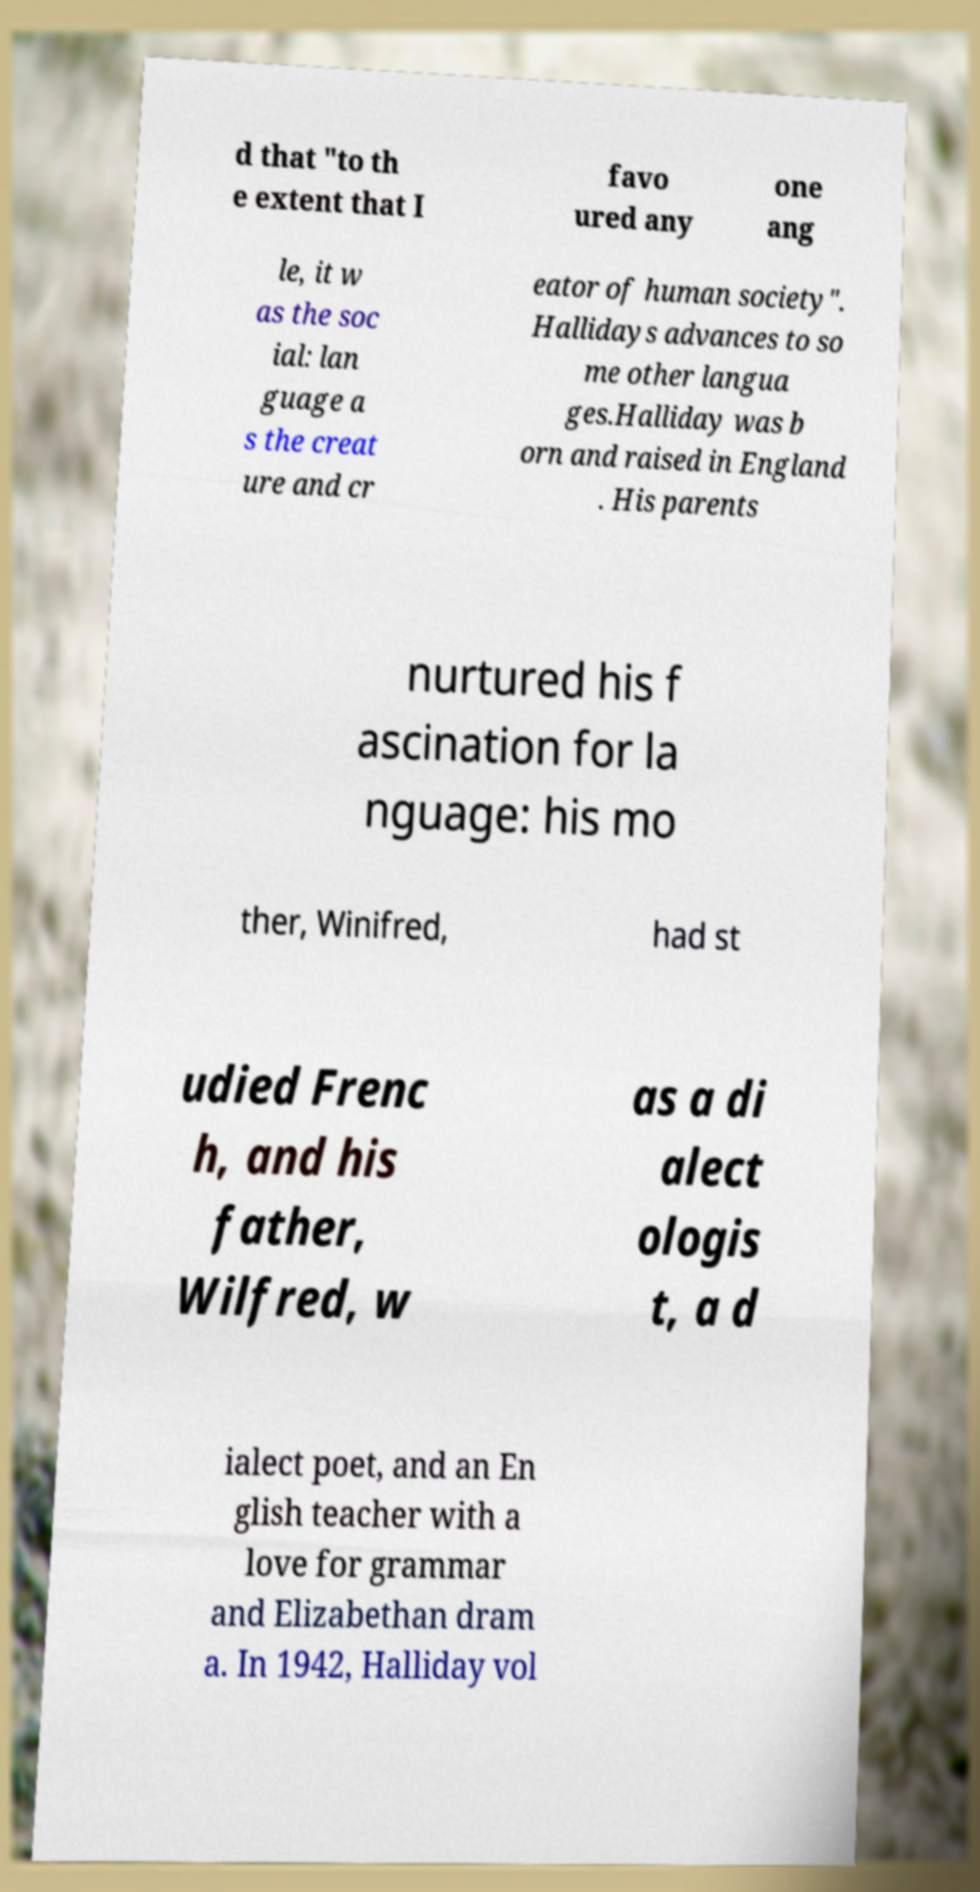There's text embedded in this image that I need extracted. Can you transcribe it verbatim? d that "to th e extent that I favo ured any one ang le, it w as the soc ial: lan guage a s the creat ure and cr eator of human society". Hallidays advances to so me other langua ges.Halliday was b orn and raised in England . His parents nurtured his f ascination for la nguage: his mo ther, Winifred, had st udied Frenc h, and his father, Wilfred, w as a di alect ologis t, a d ialect poet, and an En glish teacher with a love for grammar and Elizabethan dram a. In 1942, Halliday vol 